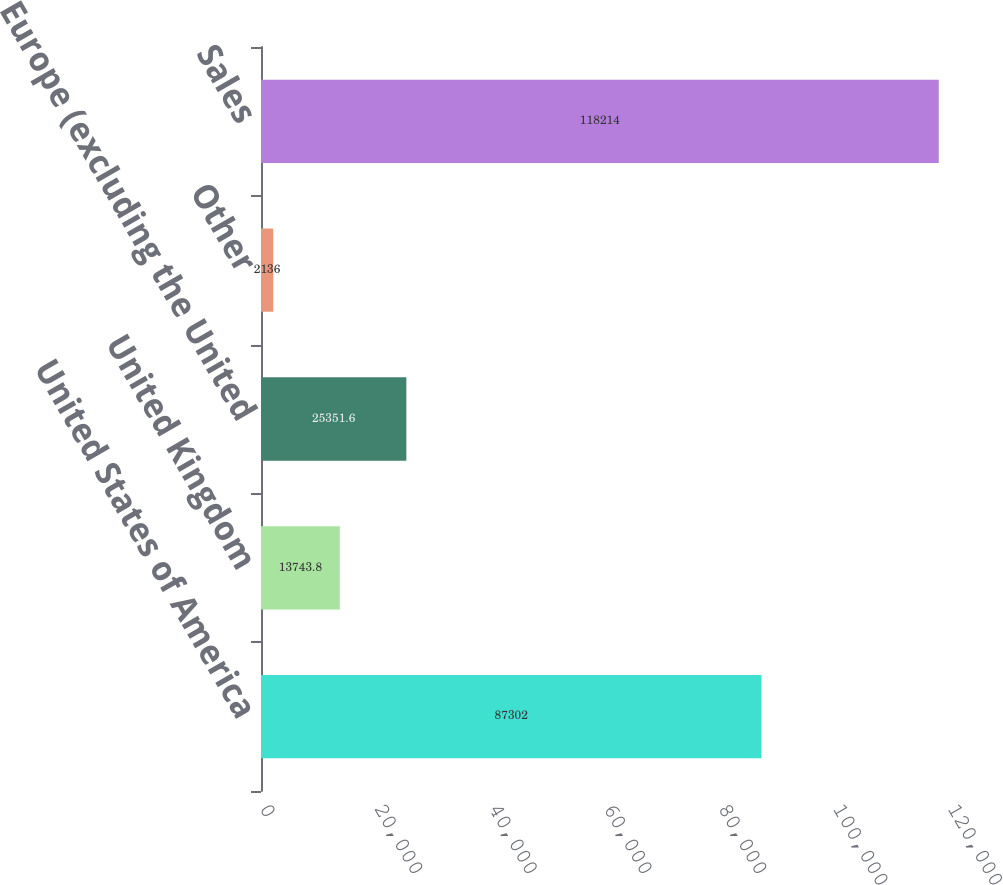Convert chart. <chart><loc_0><loc_0><loc_500><loc_500><bar_chart><fcel>United States of America<fcel>United Kingdom<fcel>Europe (excluding the United<fcel>Other<fcel>Sales<nl><fcel>87302<fcel>13743.8<fcel>25351.6<fcel>2136<fcel>118214<nl></chart> 